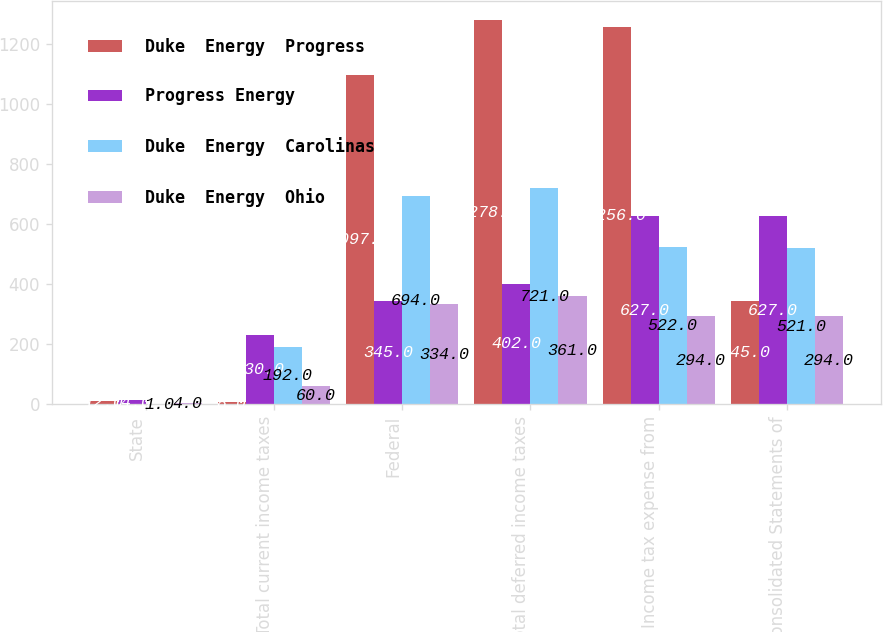Convert chart to OTSL. <chart><loc_0><loc_0><loc_500><loc_500><stacked_bar_chart><ecel><fcel>State<fcel>Total current income taxes<fcel>Federal<fcel>Total deferred income taxes<fcel>Income tax expense from<fcel>Consolidated Statements of<nl><fcel>Duke  Energy  Progress<fcel>12<fcel>8<fcel>1097<fcel>1278<fcel>1256<fcel>345<nl><fcel>Progress Energy<fcel>14<fcel>230<fcel>345<fcel>402<fcel>627<fcel>627<nl><fcel>Duke  Energy  Carolinas<fcel>1<fcel>192<fcel>694<fcel>721<fcel>522<fcel>521<nl><fcel>Duke  Energy  Ohio<fcel>4<fcel>60<fcel>334<fcel>361<fcel>294<fcel>294<nl></chart> 